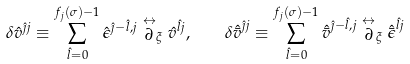Convert formula to latex. <formula><loc_0><loc_0><loc_500><loc_500>\delta { \hat { v } } ^ { { \hat { \jmath } } j } \equiv \sum _ { { \hat { l } } = 0 } ^ { f _ { j } ( \sigma ) - 1 } { \hat { \epsilon } } ^ { { \hat { \jmath } } - { \hat { l } } , j } \stackrel { \leftrightarrow } { \partial } _ { \xi } { \hat { v } } ^ { { \hat { l } } j } , \quad \delta { \hat { \bar { v } } } ^ { { \hat { \jmath } } j } \equiv \sum _ { { \hat { l } } = 0 } ^ { f _ { j } ( \sigma ) - 1 } { \hat { \bar { v } } } ^ { { \hat { \jmath } } - { \hat { l } } , j } \stackrel { \leftrightarrow } { \partial } _ { \xi } { \hat { \bar { \epsilon } } } ^ { { \hat { l } } j }</formula> 